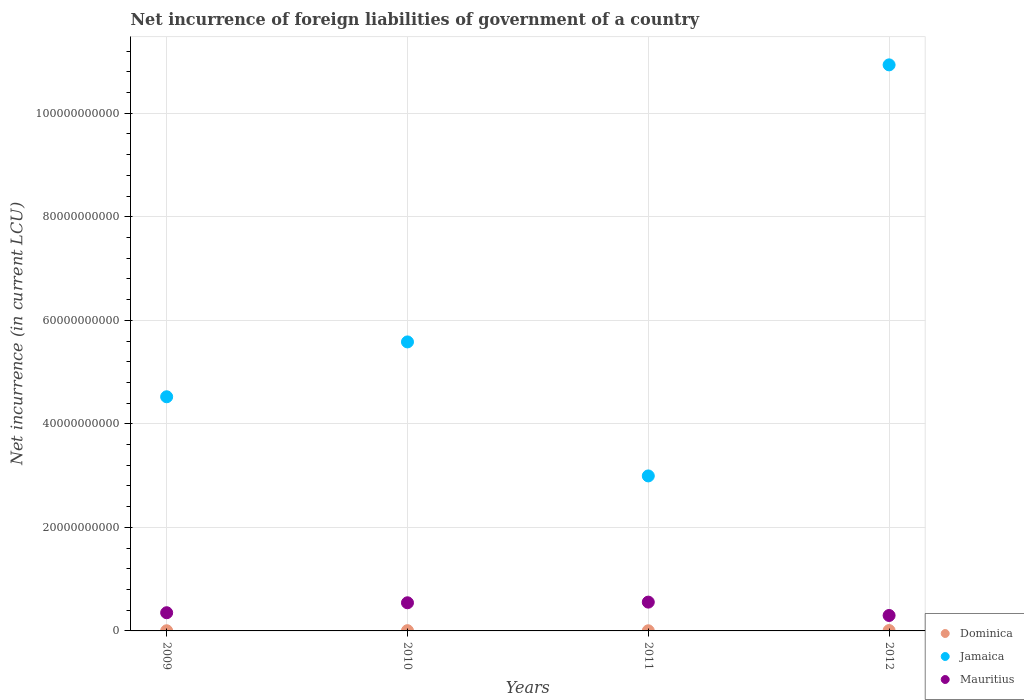How many different coloured dotlines are there?
Ensure brevity in your answer.  3. What is the net incurrence of foreign liabilities in Mauritius in 2009?
Keep it short and to the point. 3.51e+09. Across all years, what is the maximum net incurrence of foreign liabilities in Mauritius?
Give a very brief answer. 5.56e+09. Across all years, what is the minimum net incurrence of foreign liabilities in Mauritius?
Provide a short and direct response. 2.98e+09. In which year was the net incurrence of foreign liabilities in Dominica minimum?
Your response must be concise. 2011. What is the total net incurrence of foreign liabilities in Mauritius in the graph?
Your answer should be very brief. 1.75e+1. What is the difference between the net incurrence of foreign liabilities in Mauritius in 2010 and that in 2012?
Give a very brief answer. 2.45e+09. What is the difference between the net incurrence of foreign liabilities in Mauritius in 2009 and the net incurrence of foreign liabilities in Jamaica in 2012?
Your answer should be very brief. -1.06e+11. What is the average net incurrence of foreign liabilities in Dominica per year?
Keep it short and to the point. 4.47e+07. In the year 2010, what is the difference between the net incurrence of foreign liabilities in Mauritius and net incurrence of foreign liabilities in Dominica?
Offer a terse response. 5.39e+09. In how many years, is the net incurrence of foreign liabilities in Jamaica greater than 92000000000 LCU?
Give a very brief answer. 1. What is the ratio of the net incurrence of foreign liabilities in Mauritius in 2010 to that in 2011?
Keep it short and to the point. 0.98. Is the net incurrence of foreign liabilities in Jamaica in 2009 less than that in 2012?
Ensure brevity in your answer.  Yes. What is the difference between the highest and the second highest net incurrence of foreign liabilities in Mauritius?
Your answer should be compact. 1.28e+08. What is the difference between the highest and the lowest net incurrence of foreign liabilities in Mauritius?
Offer a terse response. 2.58e+09. Is the sum of the net incurrence of foreign liabilities in Dominica in 2009 and 2012 greater than the maximum net incurrence of foreign liabilities in Mauritius across all years?
Provide a succinct answer. No. Is it the case that in every year, the sum of the net incurrence of foreign liabilities in Mauritius and net incurrence of foreign liabilities in Jamaica  is greater than the net incurrence of foreign liabilities in Dominica?
Make the answer very short. Yes. Is the net incurrence of foreign liabilities in Jamaica strictly greater than the net incurrence of foreign liabilities in Mauritius over the years?
Your answer should be very brief. Yes. How many dotlines are there?
Provide a succinct answer. 3. Are the values on the major ticks of Y-axis written in scientific E-notation?
Provide a succinct answer. No. Where does the legend appear in the graph?
Offer a very short reply. Bottom right. How are the legend labels stacked?
Give a very brief answer. Vertical. What is the title of the graph?
Give a very brief answer. Net incurrence of foreign liabilities of government of a country. What is the label or title of the Y-axis?
Your answer should be very brief. Net incurrence (in current LCU). What is the Net incurrence (in current LCU) of Dominica in 2009?
Give a very brief answer. 3.07e+07. What is the Net incurrence (in current LCU) of Jamaica in 2009?
Keep it short and to the point. 4.52e+1. What is the Net incurrence (in current LCU) of Mauritius in 2009?
Provide a short and direct response. 3.51e+09. What is the Net incurrence (in current LCU) in Dominica in 2010?
Your answer should be compact. 4.80e+07. What is the Net incurrence (in current LCU) of Jamaica in 2010?
Keep it short and to the point. 5.58e+1. What is the Net incurrence (in current LCU) in Mauritius in 2010?
Make the answer very short. 5.44e+09. What is the Net incurrence (in current LCU) in Dominica in 2011?
Make the answer very short. 2.72e+07. What is the Net incurrence (in current LCU) of Jamaica in 2011?
Give a very brief answer. 2.99e+1. What is the Net incurrence (in current LCU) in Mauritius in 2011?
Your answer should be very brief. 5.56e+09. What is the Net incurrence (in current LCU) of Dominica in 2012?
Your response must be concise. 7.28e+07. What is the Net incurrence (in current LCU) in Jamaica in 2012?
Give a very brief answer. 1.09e+11. What is the Net incurrence (in current LCU) of Mauritius in 2012?
Give a very brief answer. 2.98e+09. Across all years, what is the maximum Net incurrence (in current LCU) of Dominica?
Keep it short and to the point. 7.28e+07. Across all years, what is the maximum Net incurrence (in current LCU) of Jamaica?
Provide a short and direct response. 1.09e+11. Across all years, what is the maximum Net incurrence (in current LCU) of Mauritius?
Your answer should be compact. 5.56e+09. Across all years, what is the minimum Net incurrence (in current LCU) of Dominica?
Your response must be concise. 2.72e+07. Across all years, what is the minimum Net incurrence (in current LCU) in Jamaica?
Ensure brevity in your answer.  2.99e+1. Across all years, what is the minimum Net incurrence (in current LCU) of Mauritius?
Provide a short and direct response. 2.98e+09. What is the total Net incurrence (in current LCU) of Dominica in the graph?
Offer a very short reply. 1.79e+08. What is the total Net incurrence (in current LCU) in Jamaica in the graph?
Make the answer very short. 2.40e+11. What is the total Net incurrence (in current LCU) of Mauritius in the graph?
Offer a very short reply. 1.75e+1. What is the difference between the Net incurrence (in current LCU) of Dominica in 2009 and that in 2010?
Provide a short and direct response. -1.73e+07. What is the difference between the Net incurrence (in current LCU) in Jamaica in 2009 and that in 2010?
Ensure brevity in your answer.  -1.06e+1. What is the difference between the Net incurrence (in current LCU) of Mauritius in 2009 and that in 2010?
Provide a succinct answer. -1.92e+09. What is the difference between the Net incurrence (in current LCU) in Dominica in 2009 and that in 2011?
Your answer should be very brief. 3.50e+06. What is the difference between the Net incurrence (in current LCU) of Jamaica in 2009 and that in 2011?
Your answer should be very brief. 1.53e+1. What is the difference between the Net incurrence (in current LCU) in Mauritius in 2009 and that in 2011?
Offer a very short reply. -2.05e+09. What is the difference between the Net incurrence (in current LCU) in Dominica in 2009 and that in 2012?
Your response must be concise. -4.21e+07. What is the difference between the Net incurrence (in current LCU) of Jamaica in 2009 and that in 2012?
Offer a terse response. -6.41e+1. What is the difference between the Net incurrence (in current LCU) in Mauritius in 2009 and that in 2012?
Provide a short and direct response. 5.32e+08. What is the difference between the Net incurrence (in current LCU) in Dominica in 2010 and that in 2011?
Ensure brevity in your answer.  2.08e+07. What is the difference between the Net incurrence (in current LCU) in Jamaica in 2010 and that in 2011?
Your answer should be very brief. 2.59e+1. What is the difference between the Net incurrence (in current LCU) of Mauritius in 2010 and that in 2011?
Ensure brevity in your answer.  -1.28e+08. What is the difference between the Net incurrence (in current LCU) of Dominica in 2010 and that in 2012?
Ensure brevity in your answer.  -2.48e+07. What is the difference between the Net incurrence (in current LCU) of Jamaica in 2010 and that in 2012?
Provide a short and direct response. -5.35e+1. What is the difference between the Net incurrence (in current LCU) of Mauritius in 2010 and that in 2012?
Make the answer very short. 2.45e+09. What is the difference between the Net incurrence (in current LCU) in Dominica in 2011 and that in 2012?
Offer a very short reply. -4.56e+07. What is the difference between the Net incurrence (in current LCU) in Jamaica in 2011 and that in 2012?
Offer a very short reply. -7.94e+1. What is the difference between the Net incurrence (in current LCU) in Mauritius in 2011 and that in 2012?
Make the answer very short. 2.58e+09. What is the difference between the Net incurrence (in current LCU) of Dominica in 2009 and the Net incurrence (in current LCU) of Jamaica in 2010?
Ensure brevity in your answer.  -5.58e+1. What is the difference between the Net incurrence (in current LCU) of Dominica in 2009 and the Net incurrence (in current LCU) of Mauritius in 2010?
Provide a short and direct response. -5.41e+09. What is the difference between the Net incurrence (in current LCU) of Jamaica in 2009 and the Net incurrence (in current LCU) of Mauritius in 2010?
Offer a very short reply. 3.98e+1. What is the difference between the Net incurrence (in current LCU) of Dominica in 2009 and the Net incurrence (in current LCU) of Jamaica in 2011?
Keep it short and to the point. -2.99e+1. What is the difference between the Net incurrence (in current LCU) of Dominica in 2009 and the Net incurrence (in current LCU) of Mauritius in 2011?
Provide a succinct answer. -5.53e+09. What is the difference between the Net incurrence (in current LCU) of Jamaica in 2009 and the Net incurrence (in current LCU) of Mauritius in 2011?
Your response must be concise. 3.97e+1. What is the difference between the Net incurrence (in current LCU) in Dominica in 2009 and the Net incurrence (in current LCU) in Jamaica in 2012?
Ensure brevity in your answer.  -1.09e+11. What is the difference between the Net incurrence (in current LCU) in Dominica in 2009 and the Net incurrence (in current LCU) in Mauritius in 2012?
Ensure brevity in your answer.  -2.95e+09. What is the difference between the Net incurrence (in current LCU) of Jamaica in 2009 and the Net incurrence (in current LCU) of Mauritius in 2012?
Provide a short and direct response. 4.22e+1. What is the difference between the Net incurrence (in current LCU) of Dominica in 2010 and the Net incurrence (in current LCU) of Jamaica in 2011?
Provide a succinct answer. -2.99e+1. What is the difference between the Net incurrence (in current LCU) of Dominica in 2010 and the Net incurrence (in current LCU) of Mauritius in 2011?
Provide a succinct answer. -5.52e+09. What is the difference between the Net incurrence (in current LCU) of Jamaica in 2010 and the Net incurrence (in current LCU) of Mauritius in 2011?
Your answer should be very brief. 5.03e+1. What is the difference between the Net incurrence (in current LCU) of Dominica in 2010 and the Net incurrence (in current LCU) of Jamaica in 2012?
Ensure brevity in your answer.  -1.09e+11. What is the difference between the Net incurrence (in current LCU) in Dominica in 2010 and the Net incurrence (in current LCU) in Mauritius in 2012?
Offer a very short reply. -2.93e+09. What is the difference between the Net incurrence (in current LCU) of Jamaica in 2010 and the Net incurrence (in current LCU) of Mauritius in 2012?
Ensure brevity in your answer.  5.28e+1. What is the difference between the Net incurrence (in current LCU) in Dominica in 2011 and the Net incurrence (in current LCU) in Jamaica in 2012?
Keep it short and to the point. -1.09e+11. What is the difference between the Net incurrence (in current LCU) in Dominica in 2011 and the Net incurrence (in current LCU) in Mauritius in 2012?
Your answer should be very brief. -2.96e+09. What is the difference between the Net incurrence (in current LCU) in Jamaica in 2011 and the Net incurrence (in current LCU) in Mauritius in 2012?
Offer a terse response. 2.70e+1. What is the average Net incurrence (in current LCU) of Dominica per year?
Offer a terse response. 4.47e+07. What is the average Net incurrence (in current LCU) of Jamaica per year?
Offer a very short reply. 6.01e+1. What is the average Net incurrence (in current LCU) of Mauritius per year?
Your answer should be very brief. 4.37e+09. In the year 2009, what is the difference between the Net incurrence (in current LCU) of Dominica and Net incurrence (in current LCU) of Jamaica?
Give a very brief answer. -4.52e+1. In the year 2009, what is the difference between the Net incurrence (in current LCU) in Dominica and Net incurrence (in current LCU) in Mauritius?
Your answer should be very brief. -3.48e+09. In the year 2009, what is the difference between the Net incurrence (in current LCU) in Jamaica and Net incurrence (in current LCU) in Mauritius?
Your response must be concise. 4.17e+1. In the year 2010, what is the difference between the Net incurrence (in current LCU) in Dominica and Net incurrence (in current LCU) in Jamaica?
Make the answer very short. -5.58e+1. In the year 2010, what is the difference between the Net incurrence (in current LCU) of Dominica and Net incurrence (in current LCU) of Mauritius?
Offer a very short reply. -5.39e+09. In the year 2010, what is the difference between the Net incurrence (in current LCU) in Jamaica and Net incurrence (in current LCU) in Mauritius?
Keep it short and to the point. 5.04e+1. In the year 2011, what is the difference between the Net incurrence (in current LCU) in Dominica and Net incurrence (in current LCU) in Jamaica?
Offer a very short reply. -2.99e+1. In the year 2011, what is the difference between the Net incurrence (in current LCU) in Dominica and Net incurrence (in current LCU) in Mauritius?
Your response must be concise. -5.54e+09. In the year 2011, what is the difference between the Net incurrence (in current LCU) in Jamaica and Net incurrence (in current LCU) in Mauritius?
Provide a short and direct response. 2.44e+1. In the year 2012, what is the difference between the Net incurrence (in current LCU) of Dominica and Net incurrence (in current LCU) of Jamaica?
Your answer should be very brief. -1.09e+11. In the year 2012, what is the difference between the Net incurrence (in current LCU) of Dominica and Net incurrence (in current LCU) of Mauritius?
Ensure brevity in your answer.  -2.91e+09. In the year 2012, what is the difference between the Net incurrence (in current LCU) in Jamaica and Net incurrence (in current LCU) in Mauritius?
Your answer should be compact. 1.06e+11. What is the ratio of the Net incurrence (in current LCU) in Dominica in 2009 to that in 2010?
Ensure brevity in your answer.  0.64. What is the ratio of the Net incurrence (in current LCU) in Jamaica in 2009 to that in 2010?
Ensure brevity in your answer.  0.81. What is the ratio of the Net incurrence (in current LCU) of Mauritius in 2009 to that in 2010?
Your answer should be compact. 0.65. What is the ratio of the Net incurrence (in current LCU) of Dominica in 2009 to that in 2011?
Keep it short and to the point. 1.13. What is the ratio of the Net incurrence (in current LCU) of Jamaica in 2009 to that in 2011?
Provide a succinct answer. 1.51. What is the ratio of the Net incurrence (in current LCU) of Mauritius in 2009 to that in 2011?
Your answer should be very brief. 0.63. What is the ratio of the Net incurrence (in current LCU) in Dominica in 2009 to that in 2012?
Provide a short and direct response. 0.42. What is the ratio of the Net incurrence (in current LCU) in Jamaica in 2009 to that in 2012?
Ensure brevity in your answer.  0.41. What is the ratio of the Net incurrence (in current LCU) of Mauritius in 2009 to that in 2012?
Keep it short and to the point. 1.18. What is the ratio of the Net incurrence (in current LCU) of Dominica in 2010 to that in 2011?
Your response must be concise. 1.76. What is the ratio of the Net incurrence (in current LCU) in Jamaica in 2010 to that in 2011?
Provide a succinct answer. 1.86. What is the ratio of the Net incurrence (in current LCU) in Mauritius in 2010 to that in 2011?
Offer a very short reply. 0.98. What is the ratio of the Net incurrence (in current LCU) of Dominica in 2010 to that in 2012?
Your response must be concise. 0.66. What is the ratio of the Net incurrence (in current LCU) of Jamaica in 2010 to that in 2012?
Provide a short and direct response. 0.51. What is the ratio of the Net incurrence (in current LCU) of Mauritius in 2010 to that in 2012?
Make the answer very short. 1.82. What is the ratio of the Net incurrence (in current LCU) in Dominica in 2011 to that in 2012?
Your answer should be compact. 0.37. What is the ratio of the Net incurrence (in current LCU) in Jamaica in 2011 to that in 2012?
Keep it short and to the point. 0.27. What is the ratio of the Net incurrence (in current LCU) of Mauritius in 2011 to that in 2012?
Provide a succinct answer. 1.87. What is the difference between the highest and the second highest Net incurrence (in current LCU) of Dominica?
Make the answer very short. 2.48e+07. What is the difference between the highest and the second highest Net incurrence (in current LCU) of Jamaica?
Offer a terse response. 5.35e+1. What is the difference between the highest and the second highest Net incurrence (in current LCU) of Mauritius?
Keep it short and to the point. 1.28e+08. What is the difference between the highest and the lowest Net incurrence (in current LCU) of Dominica?
Provide a short and direct response. 4.56e+07. What is the difference between the highest and the lowest Net incurrence (in current LCU) in Jamaica?
Offer a very short reply. 7.94e+1. What is the difference between the highest and the lowest Net incurrence (in current LCU) of Mauritius?
Ensure brevity in your answer.  2.58e+09. 